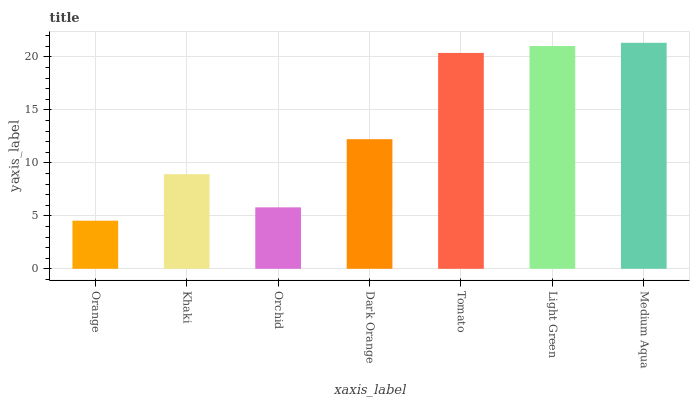Is Khaki the minimum?
Answer yes or no. No. Is Khaki the maximum?
Answer yes or no. No. Is Khaki greater than Orange?
Answer yes or no. Yes. Is Orange less than Khaki?
Answer yes or no. Yes. Is Orange greater than Khaki?
Answer yes or no. No. Is Khaki less than Orange?
Answer yes or no. No. Is Dark Orange the high median?
Answer yes or no. Yes. Is Dark Orange the low median?
Answer yes or no. Yes. Is Light Green the high median?
Answer yes or no. No. Is Orange the low median?
Answer yes or no. No. 